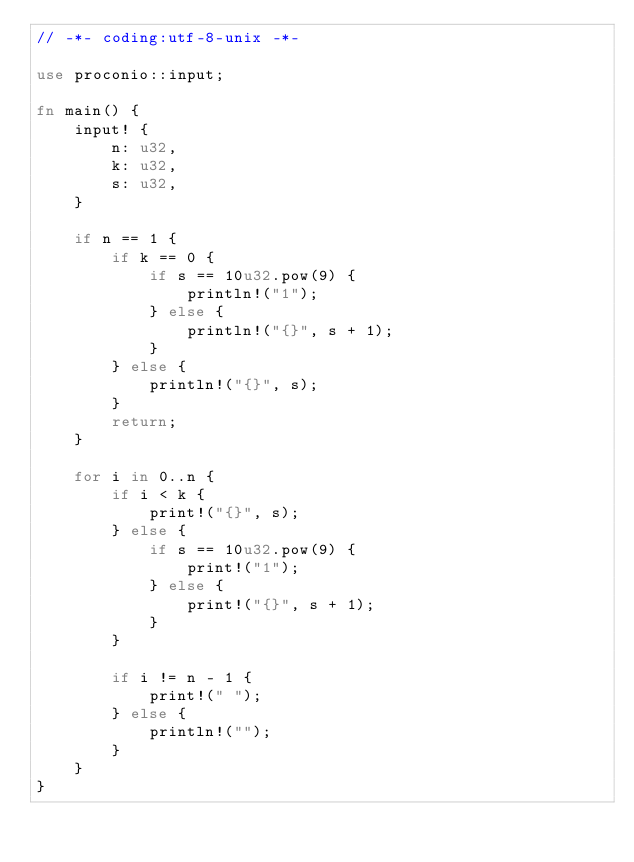Convert code to text. <code><loc_0><loc_0><loc_500><loc_500><_Rust_>// -*- coding:utf-8-unix -*-

use proconio::input;

fn main() {
    input! {
        n: u32,
        k: u32,
        s: u32,
    }

    if n == 1 {
        if k == 0 {
            if s == 10u32.pow(9) {
                println!("1");
            } else {
                println!("{}", s + 1);
            }
        } else {
            println!("{}", s);
        }
        return;
    }

    for i in 0..n {
        if i < k {
            print!("{}", s);
        } else {
            if s == 10u32.pow(9) {
                print!("1");
            } else {
                print!("{}", s + 1);
            }
        }

        if i != n - 1 {
            print!(" ");
        } else {
            println!("");
        }
    }
}
</code> 